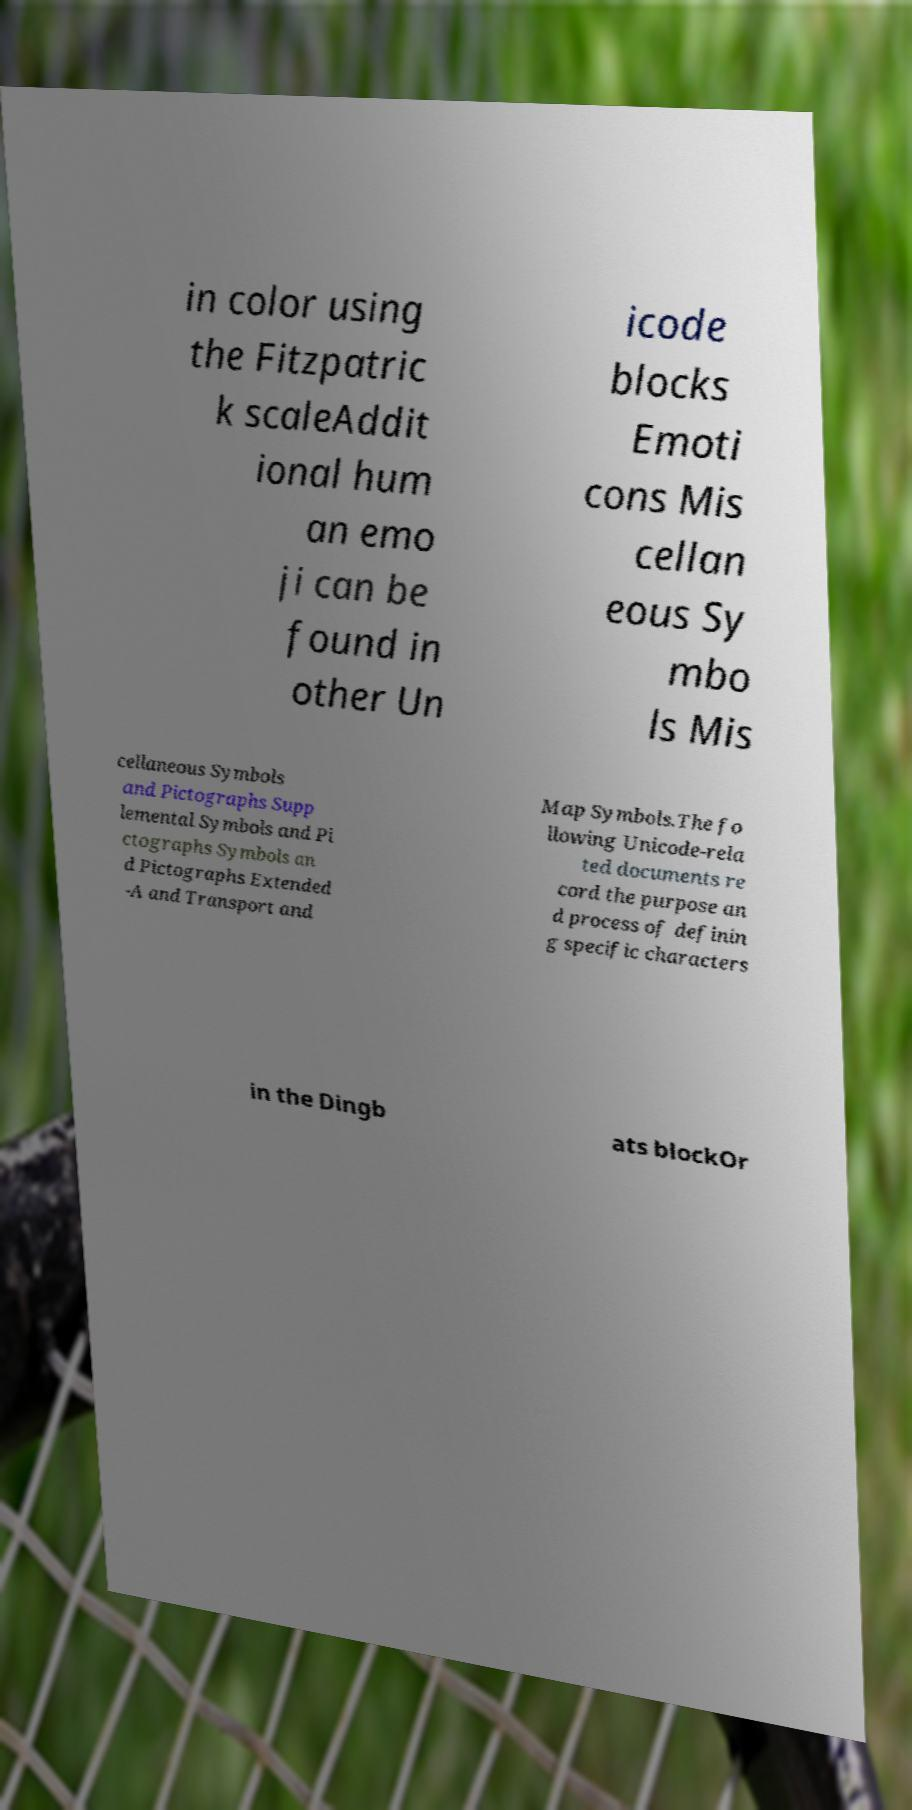Could you extract and type out the text from this image? in color using the Fitzpatric k scaleAddit ional hum an emo ji can be found in other Un icode blocks Emoti cons Mis cellan eous Sy mbo ls Mis cellaneous Symbols and Pictographs Supp lemental Symbols and Pi ctographs Symbols an d Pictographs Extended -A and Transport and Map Symbols.The fo llowing Unicode-rela ted documents re cord the purpose an d process of definin g specific characters in the Dingb ats blockOr 